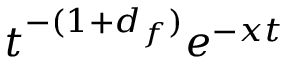<formula> <loc_0><loc_0><loc_500><loc_500>t ^ { - ( 1 + d _ { f } ) } e ^ { - x t }</formula> 